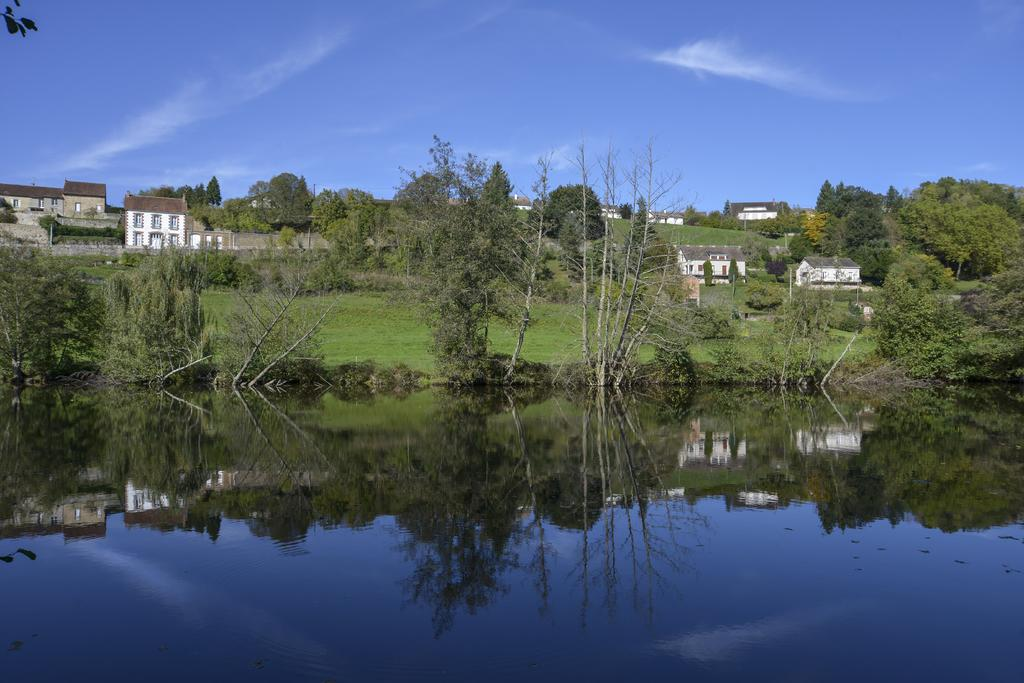What type of structures can be seen in the image? There are buildings in the image. What other natural elements are present in the image? There are trees and water visible in the image. How would you describe the sky in the image? The sky is blue and cloudy in the image. Where is the stove and flame located in the image? There is no stove or flame present in the image. What type of prose can be read in the image? There is no prose visible in the image. 